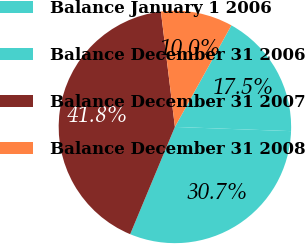<chart> <loc_0><loc_0><loc_500><loc_500><pie_chart><fcel>Balance January 1 2006<fcel>Balance December 31 2006<fcel>Balance December 31 2007<fcel>Balance December 31 2008<nl><fcel>17.5%<fcel>30.71%<fcel>41.79%<fcel>10.0%<nl></chart> 